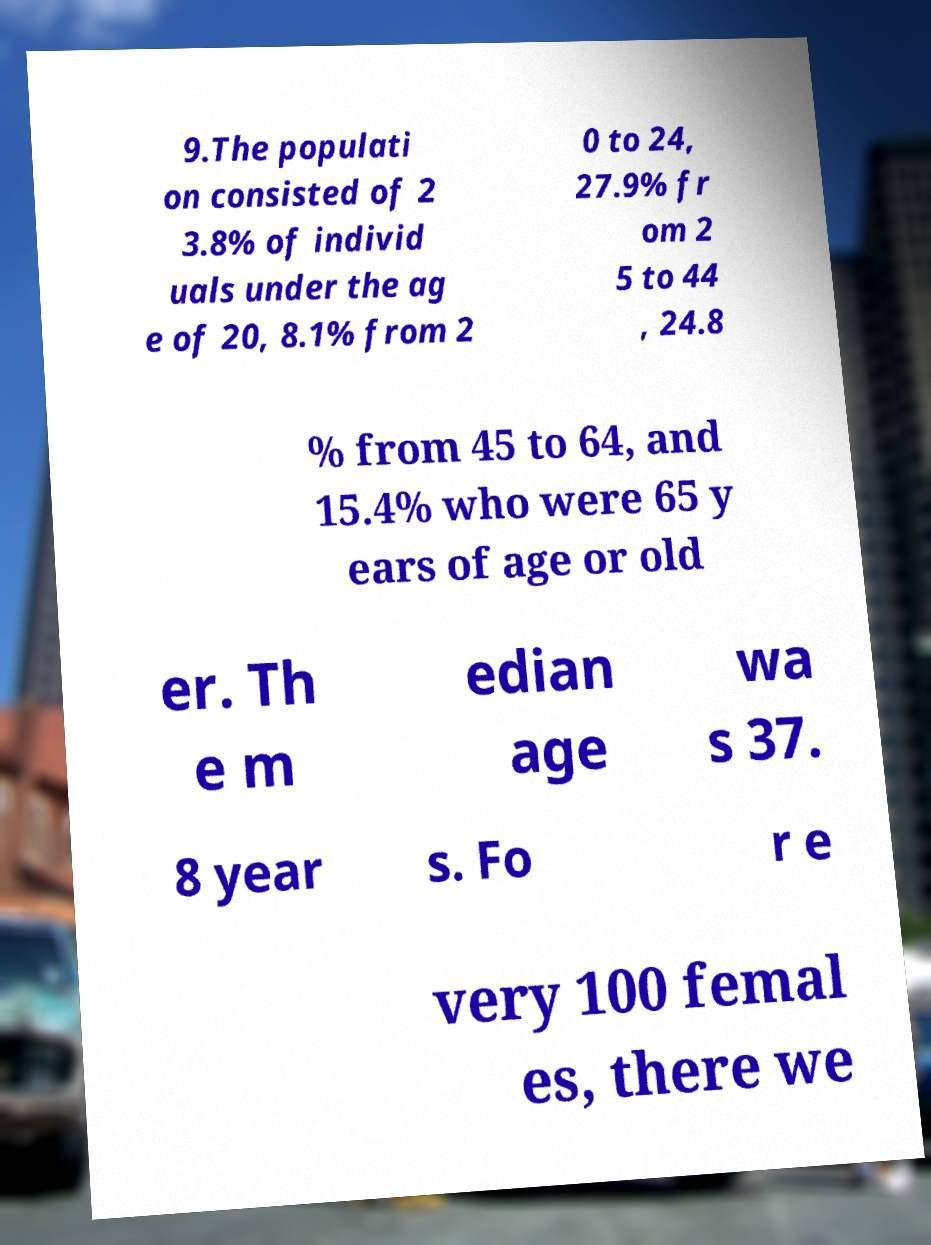There's text embedded in this image that I need extracted. Can you transcribe it verbatim? 9.The populati on consisted of 2 3.8% of individ uals under the ag e of 20, 8.1% from 2 0 to 24, 27.9% fr om 2 5 to 44 , 24.8 % from 45 to 64, and 15.4% who were 65 y ears of age or old er. Th e m edian age wa s 37. 8 year s. Fo r e very 100 femal es, there we 